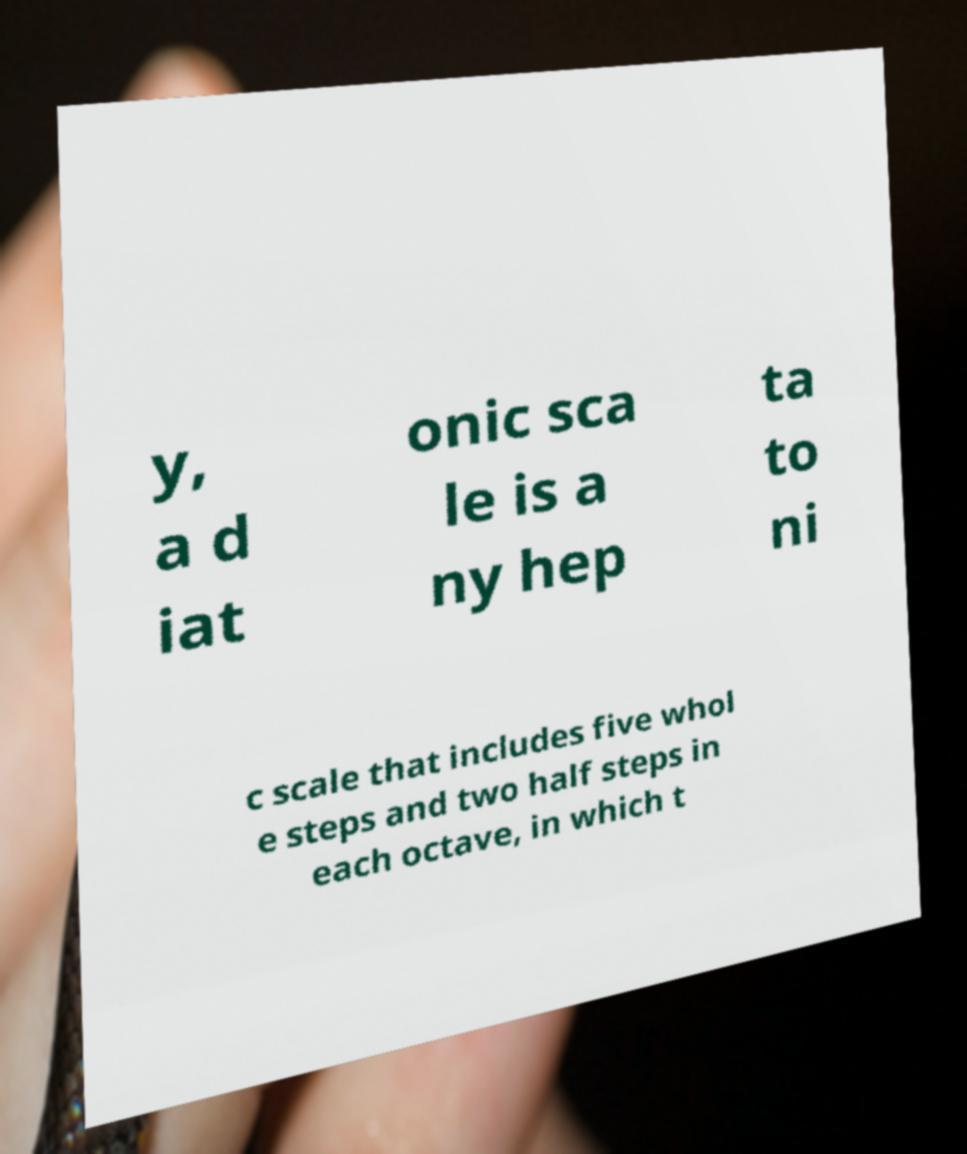Could you assist in decoding the text presented in this image and type it out clearly? y, a d iat onic sca le is a ny hep ta to ni c scale that includes five whol e steps and two half steps in each octave, in which t 